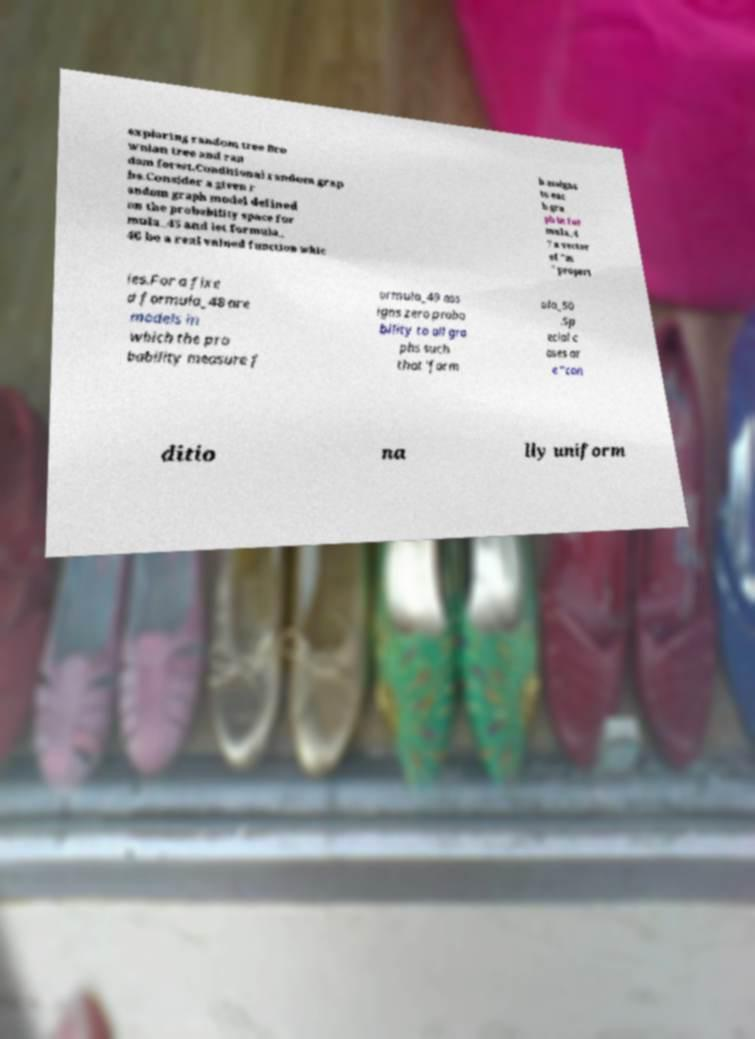Can you accurately transcribe the text from the provided image for me? exploring random tree Bro wnian tree and ran dom forest.Conditional random grap hs.Consider a given r andom graph model defined on the probability space for mula_45 and let formula_ 46 be a real valued function whic h assigns to eac h gra ph in for mula_4 7 a vector of "m " propert ies.For a fixe d formula_48 are models in which the pro bability measure f ormula_49 ass igns zero proba bility to all gra phs such that 'form ula_50 .Sp ecial c ases ar e "con ditio na lly uniform 